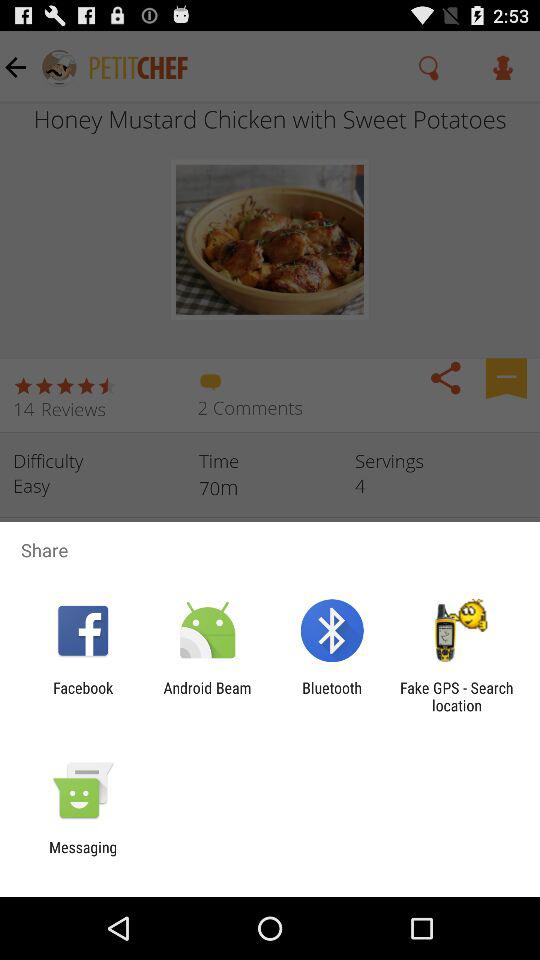How many more reviews does this recipe have than comments?
Answer the question using a single word or phrase. 12 